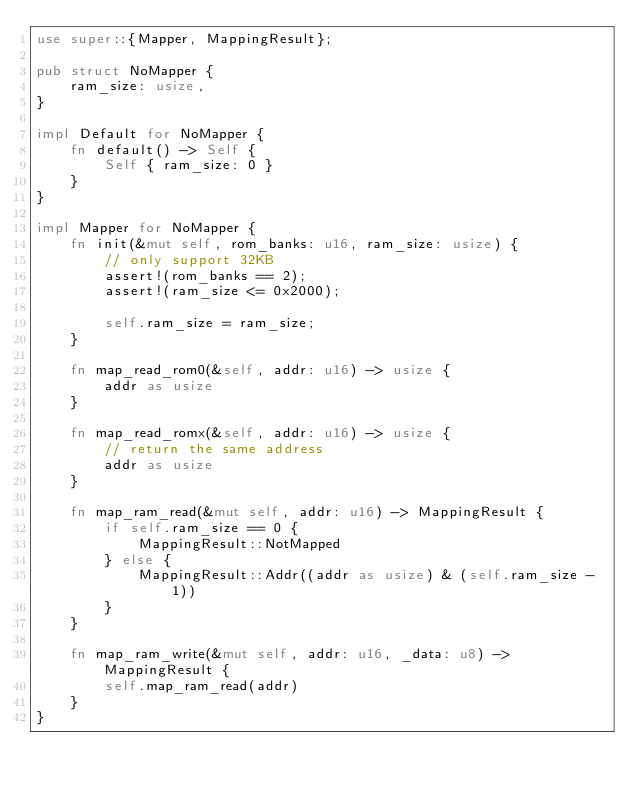Convert code to text. <code><loc_0><loc_0><loc_500><loc_500><_Rust_>use super::{Mapper, MappingResult};

pub struct NoMapper {
    ram_size: usize,
}

impl Default for NoMapper {
    fn default() -> Self {
        Self { ram_size: 0 }
    }
}

impl Mapper for NoMapper {
    fn init(&mut self, rom_banks: u16, ram_size: usize) {
        // only support 32KB
        assert!(rom_banks == 2);
        assert!(ram_size <= 0x2000);

        self.ram_size = ram_size;
    }

    fn map_read_rom0(&self, addr: u16) -> usize {
        addr as usize
    }

    fn map_read_romx(&self, addr: u16) -> usize {
        // return the same address
        addr as usize
    }

    fn map_ram_read(&mut self, addr: u16) -> MappingResult {
        if self.ram_size == 0 {
            MappingResult::NotMapped
        } else {
            MappingResult::Addr((addr as usize) & (self.ram_size - 1))
        }
    }

    fn map_ram_write(&mut self, addr: u16, _data: u8) -> MappingResult {
        self.map_ram_read(addr)
    }
}
</code> 